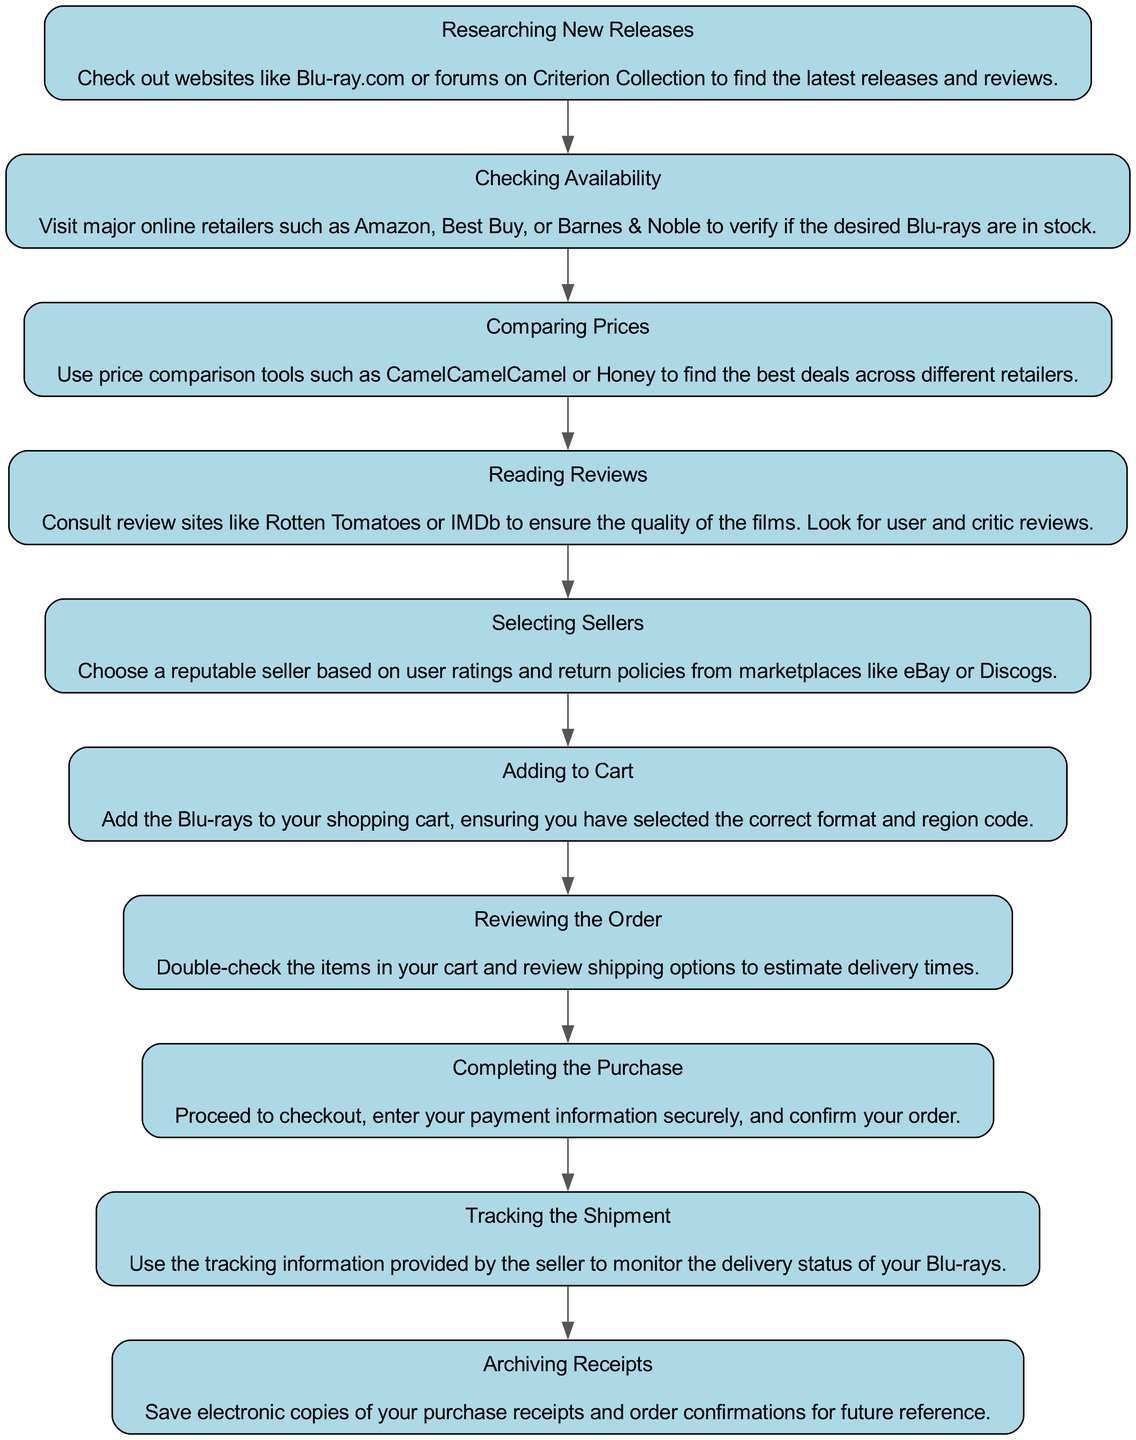What is the first step listed in the diagram? The flowchart starts with "Researching New Releases," which is the first node in the sequence of steps shown.
Answer: Researching New Releases How many total steps are in the selection process? There are ten steps outlined in the flowchart, as indicated by the nodes sequentially listed.
Answer: 10 What action follows "Checking Availability"? The flowchart indicates that the step directly after "Checking Availability" is "Comparing Prices." This is the next step in the sequence.
Answer: Comparing Prices Which step emphasizes the importance of user ratings? The step titled "Selecting Sellers" stresses the importance of user ratings when choosing a reputable seller.
Answer: Selecting Sellers What is the last step mentioned in the selection process? The final step, according to the flowchart, is "Archiving Receipts," which wraps up the series of actions to be taken after the purchase.
Answer: Archiving Receipts What should be done after "Reviewing the Order"? The action that comes after "Reviewing the Order" is "Completing the Purchase," which follows the verification of cart items and shipping options.
Answer: Completing the Purchase How does one ensure the quality of the films according to the flowchart? To ensure film quality, the step "Reading Reviews" advises consulting review sites like Rotten Tomatoes or IMDb for feedback.
Answer: Reading Reviews What is the objective of using price comparison tools? The purpose of utilizing price comparison tools as indicated in the diagram is to find the best deals across different retailers.
Answer: Best deals Which step involves tracking delivery status? "Tracking the Shipment" is the designated step for monitoring the delivery status of the Blu-rays purchased.
Answer: Tracking the Shipment 